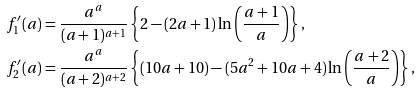Convert formula to latex. <formula><loc_0><loc_0><loc_500><loc_500>f ^ { \prime } _ { 1 } ( a ) & = \frac { a ^ { a } } { ( a + 1 ) ^ { a + 1 } } \left \{ 2 - ( 2 a + 1 ) \ln \left ( \frac { a + 1 } { a } \right ) \right \} , \\ f ^ { \prime } _ { 2 } ( a ) & = \frac { a ^ { a } } { ( a + 2 ) ^ { a + 2 } } \left \{ ( 1 0 a + 1 0 ) - ( 5 a ^ { 2 } + 1 0 a + 4 ) \ln \left ( \frac { a + 2 } { a } \right ) \right \} ,</formula> 